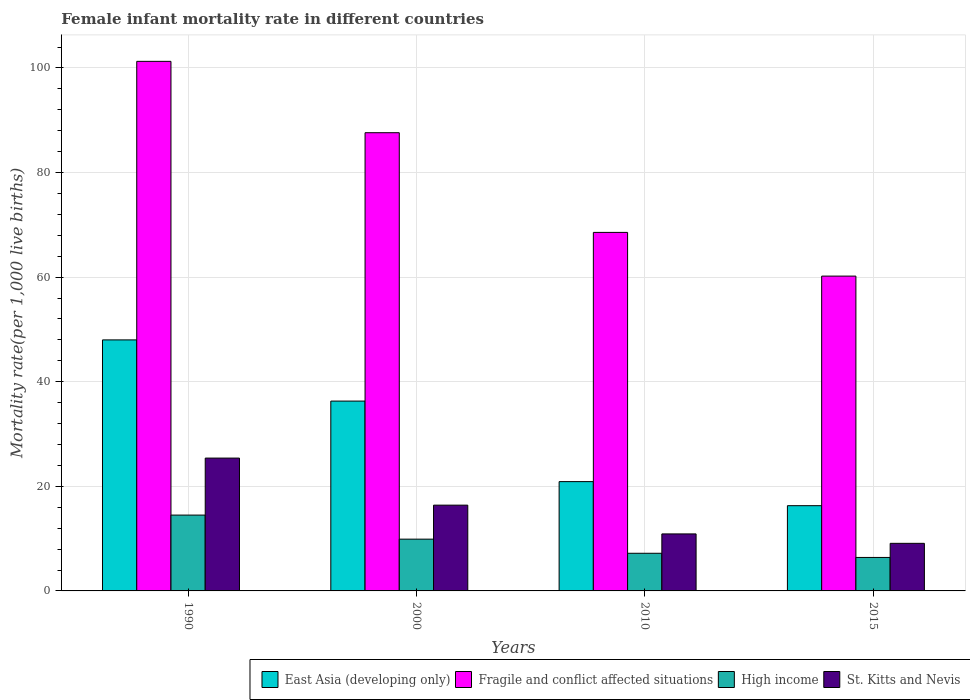How many different coloured bars are there?
Your response must be concise. 4. How many bars are there on the 1st tick from the left?
Provide a succinct answer. 4. How many bars are there on the 4th tick from the right?
Your answer should be compact. 4. What is the female infant mortality rate in East Asia (developing only) in 1990?
Give a very brief answer. 48. Across all years, what is the maximum female infant mortality rate in East Asia (developing only)?
Provide a short and direct response. 48. Across all years, what is the minimum female infant mortality rate in Fragile and conflict affected situations?
Offer a terse response. 60.2. In which year was the female infant mortality rate in High income minimum?
Provide a succinct answer. 2015. What is the total female infant mortality rate in Fragile and conflict affected situations in the graph?
Provide a succinct answer. 317.63. What is the difference between the female infant mortality rate in High income in 1990 and that in 2010?
Keep it short and to the point. 7.3. What is the difference between the female infant mortality rate in Fragile and conflict affected situations in 2010 and the female infant mortality rate in High income in 2015?
Provide a short and direct response. 62.15. What is the average female infant mortality rate in East Asia (developing only) per year?
Your answer should be very brief. 30.37. In the year 1990, what is the difference between the female infant mortality rate in East Asia (developing only) and female infant mortality rate in St. Kitts and Nevis?
Provide a succinct answer. 22.6. In how many years, is the female infant mortality rate in High income greater than 92?
Your answer should be compact. 0. What is the ratio of the female infant mortality rate in High income in 2000 to that in 2015?
Provide a succinct answer. 1.55. Is the female infant mortality rate in East Asia (developing only) in 2000 less than that in 2010?
Keep it short and to the point. No. Is the difference between the female infant mortality rate in East Asia (developing only) in 2000 and 2010 greater than the difference between the female infant mortality rate in St. Kitts and Nevis in 2000 and 2010?
Your answer should be compact. Yes. What is the difference between the highest and the second highest female infant mortality rate in High income?
Offer a terse response. 4.6. What is the difference between the highest and the lowest female infant mortality rate in East Asia (developing only)?
Ensure brevity in your answer.  31.7. In how many years, is the female infant mortality rate in East Asia (developing only) greater than the average female infant mortality rate in East Asia (developing only) taken over all years?
Offer a very short reply. 2. Is the sum of the female infant mortality rate in St. Kitts and Nevis in 1990 and 2000 greater than the maximum female infant mortality rate in East Asia (developing only) across all years?
Make the answer very short. No. What does the 4th bar from the left in 1990 represents?
Provide a short and direct response. St. Kitts and Nevis. What does the 2nd bar from the right in 2015 represents?
Give a very brief answer. High income. How many bars are there?
Provide a succinct answer. 16. Are all the bars in the graph horizontal?
Your answer should be compact. No. How many legend labels are there?
Offer a very short reply. 4. What is the title of the graph?
Offer a very short reply. Female infant mortality rate in different countries. Does "Belize" appear as one of the legend labels in the graph?
Provide a succinct answer. No. What is the label or title of the X-axis?
Keep it short and to the point. Years. What is the label or title of the Y-axis?
Your response must be concise. Mortality rate(per 1,0 live births). What is the Mortality rate(per 1,000 live births) in Fragile and conflict affected situations in 1990?
Give a very brief answer. 101.26. What is the Mortality rate(per 1,000 live births) in St. Kitts and Nevis in 1990?
Offer a terse response. 25.4. What is the Mortality rate(per 1,000 live births) in East Asia (developing only) in 2000?
Keep it short and to the point. 36.3. What is the Mortality rate(per 1,000 live births) in Fragile and conflict affected situations in 2000?
Your answer should be very brief. 87.62. What is the Mortality rate(per 1,000 live births) in High income in 2000?
Make the answer very short. 9.9. What is the Mortality rate(per 1,000 live births) of East Asia (developing only) in 2010?
Offer a very short reply. 20.9. What is the Mortality rate(per 1,000 live births) in Fragile and conflict affected situations in 2010?
Your response must be concise. 68.55. What is the Mortality rate(per 1,000 live births) of St. Kitts and Nevis in 2010?
Your answer should be very brief. 10.9. What is the Mortality rate(per 1,000 live births) of Fragile and conflict affected situations in 2015?
Make the answer very short. 60.2. Across all years, what is the maximum Mortality rate(per 1,000 live births) of East Asia (developing only)?
Offer a very short reply. 48. Across all years, what is the maximum Mortality rate(per 1,000 live births) of Fragile and conflict affected situations?
Ensure brevity in your answer.  101.26. Across all years, what is the maximum Mortality rate(per 1,000 live births) of St. Kitts and Nevis?
Offer a terse response. 25.4. Across all years, what is the minimum Mortality rate(per 1,000 live births) of East Asia (developing only)?
Your answer should be very brief. 16.3. Across all years, what is the minimum Mortality rate(per 1,000 live births) in Fragile and conflict affected situations?
Provide a short and direct response. 60.2. Across all years, what is the minimum Mortality rate(per 1,000 live births) of St. Kitts and Nevis?
Make the answer very short. 9.1. What is the total Mortality rate(per 1,000 live births) of East Asia (developing only) in the graph?
Offer a terse response. 121.5. What is the total Mortality rate(per 1,000 live births) of Fragile and conflict affected situations in the graph?
Make the answer very short. 317.63. What is the total Mortality rate(per 1,000 live births) in St. Kitts and Nevis in the graph?
Provide a succinct answer. 61.8. What is the difference between the Mortality rate(per 1,000 live births) in Fragile and conflict affected situations in 1990 and that in 2000?
Provide a succinct answer. 13.64. What is the difference between the Mortality rate(per 1,000 live births) of East Asia (developing only) in 1990 and that in 2010?
Ensure brevity in your answer.  27.1. What is the difference between the Mortality rate(per 1,000 live births) in Fragile and conflict affected situations in 1990 and that in 2010?
Your response must be concise. 32.71. What is the difference between the Mortality rate(per 1,000 live births) in St. Kitts and Nevis in 1990 and that in 2010?
Provide a short and direct response. 14.5. What is the difference between the Mortality rate(per 1,000 live births) of East Asia (developing only) in 1990 and that in 2015?
Keep it short and to the point. 31.7. What is the difference between the Mortality rate(per 1,000 live births) of Fragile and conflict affected situations in 1990 and that in 2015?
Your response must be concise. 41.06. What is the difference between the Mortality rate(per 1,000 live births) in High income in 1990 and that in 2015?
Your answer should be very brief. 8.1. What is the difference between the Mortality rate(per 1,000 live births) of Fragile and conflict affected situations in 2000 and that in 2010?
Your answer should be compact. 19.06. What is the difference between the Mortality rate(per 1,000 live births) of High income in 2000 and that in 2010?
Make the answer very short. 2.7. What is the difference between the Mortality rate(per 1,000 live births) in Fragile and conflict affected situations in 2000 and that in 2015?
Offer a terse response. 27.42. What is the difference between the Mortality rate(per 1,000 live births) in Fragile and conflict affected situations in 2010 and that in 2015?
Keep it short and to the point. 8.36. What is the difference between the Mortality rate(per 1,000 live births) in High income in 2010 and that in 2015?
Offer a very short reply. 0.8. What is the difference between the Mortality rate(per 1,000 live births) of East Asia (developing only) in 1990 and the Mortality rate(per 1,000 live births) of Fragile and conflict affected situations in 2000?
Your response must be concise. -39.62. What is the difference between the Mortality rate(per 1,000 live births) in East Asia (developing only) in 1990 and the Mortality rate(per 1,000 live births) in High income in 2000?
Offer a terse response. 38.1. What is the difference between the Mortality rate(per 1,000 live births) of East Asia (developing only) in 1990 and the Mortality rate(per 1,000 live births) of St. Kitts and Nevis in 2000?
Provide a succinct answer. 31.6. What is the difference between the Mortality rate(per 1,000 live births) of Fragile and conflict affected situations in 1990 and the Mortality rate(per 1,000 live births) of High income in 2000?
Your answer should be very brief. 91.36. What is the difference between the Mortality rate(per 1,000 live births) in Fragile and conflict affected situations in 1990 and the Mortality rate(per 1,000 live births) in St. Kitts and Nevis in 2000?
Make the answer very short. 84.86. What is the difference between the Mortality rate(per 1,000 live births) in High income in 1990 and the Mortality rate(per 1,000 live births) in St. Kitts and Nevis in 2000?
Give a very brief answer. -1.9. What is the difference between the Mortality rate(per 1,000 live births) in East Asia (developing only) in 1990 and the Mortality rate(per 1,000 live births) in Fragile and conflict affected situations in 2010?
Your answer should be very brief. -20.55. What is the difference between the Mortality rate(per 1,000 live births) in East Asia (developing only) in 1990 and the Mortality rate(per 1,000 live births) in High income in 2010?
Your answer should be very brief. 40.8. What is the difference between the Mortality rate(per 1,000 live births) of East Asia (developing only) in 1990 and the Mortality rate(per 1,000 live births) of St. Kitts and Nevis in 2010?
Provide a succinct answer. 37.1. What is the difference between the Mortality rate(per 1,000 live births) of Fragile and conflict affected situations in 1990 and the Mortality rate(per 1,000 live births) of High income in 2010?
Your answer should be very brief. 94.06. What is the difference between the Mortality rate(per 1,000 live births) of Fragile and conflict affected situations in 1990 and the Mortality rate(per 1,000 live births) of St. Kitts and Nevis in 2010?
Your answer should be compact. 90.36. What is the difference between the Mortality rate(per 1,000 live births) of East Asia (developing only) in 1990 and the Mortality rate(per 1,000 live births) of Fragile and conflict affected situations in 2015?
Offer a very short reply. -12.2. What is the difference between the Mortality rate(per 1,000 live births) of East Asia (developing only) in 1990 and the Mortality rate(per 1,000 live births) of High income in 2015?
Provide a short and direct response. 41.6. What is the difference between the Mortality rate(per 1,000 live births) of East Asia (developing only) in 1990 and the Mortality rate(per 1,000 live births) of St. Kitts and Nevis in 2015?
Keep it short and to the point. 38.9. What is the difference between the Mortality rate(per 1,000 live births) of Fragile and conflict affected situations in 1990 and the Mortality rate(per 1,000 live births) of High income in 2015?
Provide a short and direct response. 94.86. What is the difference between the Mortality rate(per 1,000 live births) in Fragile and conflict affected situations in 1990 and the Mortality rate(per 1,000 live births) in St. Kitts and Nevis in 2015?
Provide a succinct answer. 92.16. What is the difference between the Mortality rate(per 1,000 live births) in High income in 1990 and the Mortality rate(per 1,000 live births) in St. Kitts and Nevis in 2015?
Give a very brief answer. 5.4. What is the difference between the Mortality rate(per 1,000 live births) of East Asia (developing only) in 2000 and the Mortality rate(per 1,000 live births) of Fragile and conflict affected situations in 2010?
Your answer should be very brief. -32.25. What is the difference between the Mortality rate(per 1,000 live births) in East Asia (developing only) in 2000 and the Mortality rate(per 1,000 live births) in High income in 2010?
Your answer should be compact. 29.1. What is the difference between the Mortality rate(per 1,000 live births) in East Asia (developing only) in 2000 and the Mortality rate(per 1,000 live births) in St. Kitts and Nevis in 2010?
Offer a very short reply. 25.4. What is the difference between the Mortality rate(per 1,000 live births) in Fragile and conflict affected situations in 2000 and the Mortality rate(per 1,000 live births) in High income in 2010?
Give a very brief answer. 80.42. What is the difference between the Mortality rate(per 1,000 live births) in Fragile and conflict affected situations in 2000 and the Mortality rate(per 1,000 live births) in St. Kitts and Nevis in 2010?
Offer a very short reply. 76.72. What is the difference between the Mortality rate(per 1,000 live births) in East Asia (developing only) in 2000 and the Mortality rate(per 1,000 live births) in Fragile and conflict affected situations in 2015?
Give a very brief answer. -23.9. What is the difference between the Mortality rate(per 1,000 live births) of East Asia (developing only) in 2000 and the Mortality rate(per 1,000 live births) of High income in 2015?
Offer a terse response. 29.9. What is the difference between the Mortality rate(per 1,000 live births) in East Asia (developing only) in 2000 and the Mortality rate(per 1,000 live births) in St. Kitts and Nevis in 2015?
Offer a terse response. 27.2. What is the difference between the Mortality rate(per 1,000 live births) of Fragile and conflict affected situations in 2000 and the Mortality rate(per 1,000 live births) of High income in 2015?
Your answer should be compact. 81.22. What is the difference between the Mortality rate(per 1,000 live births) of Fragile and conflict affected situations in 2000 and the Mortality rate(per 1,000 live births) of St. Kitts and Nevis in 2015?
Keep it short and to the point. 78.52. What is the difference between the Mortality rate(per 1,000 live births) of High income in 2000 and the Mortality rate(per 1,000 live births) of St. Kitts and Nevis in 2015?
Keep it short and to the point. 0.8. What is the difference between the Mortality rate(per 1,000 live births) in East Asia (developing only) in 2010 and the Mortality rate(per 1,000 live births) in Fragile and conflict affected situations in 2015?
Give a very brief answer. -39.3. What is the difference between the Mortality rate(per 1,000 live births) of East Asia (developing only) in 2010 and the Mortality rate(per 1,000 live births) of St. Kitts and Nevis in 2015?
Keep it short and to the point. 11.8. What is the difference between the Mortality rate(per 1,000 live births) in Fragile and conflict affected situations in 2010 and the Mortality rate(per 1,000 live births) in High income in 2015?
Keep it short and to the point. 62.15. What is the difference between the Mortality rate(per 1,000 live births) of Fragile and conflict affected situations in 2010 and the Mortality rate(per 1,000 live births) of St. Kitts and Nevis in 2015?
Offer a very short reply. 59.45. What is the average Mortality rate(per 1,000 live births) of East Asia (developing only) per year?
Make the answer very short. 30.38. What is the average Mortality rate(per 1,000 live births) of Fragile and conflict affected situations per year?
Your answer should be very brief. 79.41. What is the average Mortality rate(per 1,000 live births) in St. Kitts and Nevis per year?
Keep it short and to the point. 15.45. In the year 1990, what is the difference between the Mortality rate(per 1,000 live births) in East Asia (developing only) and Mortality rate(per 1,000 live births) in Fragile and conflict affected situations?
Your answer should be compact. -53.26. In the year 1990, what is the difference between the Mortality rate(per 1,000 live births) of East Asia (developing only) and Mortality rate(per 1,000 live births) of High income?
Offer a terse response. 33.5. In the year 1990, what is the difference between the Mortality rate(per 1,000 live births) of East Asia (developing only) and Mortality rate(per 1,000 live births) of St. Kitts and Nevis?
Make the answer very short. 22.6. In the year 1990, what is the difference between the Mortality rate(per 1,000 live births) in Fragile and conflict affected situations and Mortality rate(per 1,000 live births) in High income?
Offer a very short reply. 86.76. In the year 1990, what is the difference between the Mortality rate(per 1,000 live births) in Fragile and conflict affected situations and Mortality rate(per 1,000 live births) in St. Kitts and Nevis?
Give a very brief answer. 75.86. In the year 2000, what is the difference between the Mortality rate(per 1,000 live births) of East Asia (developing only) and Mortality rate(per 1,000 live births) of Fragile and conflict affected situations?
Your response must be concise. -51.32. In the year 2000, what is the difference between the Mortality rate(per 1,000 live births) in East Asia (developing only) and Mortality rate(per 1,000 live births) in High income?
Your response must be concise. 26.4. In the year 2000, what is the difference between the Mortality rate(per 1,000 live births) of Fragile and conflict affected situations and Mortality rate(per 1,000 live births) of High income?
Your answer should be very brief. 77.72. In the year 2000, what is the difference between the Mortality rate(per 1,000 live births) of Fragile and conflict affected situations and Mortality rate(per 1,000 live births) of St. Kitts and Nevis?
Provide a succinct answer. 71.22. In the year 2000, what is the difference between the Mortality rate(per 1,000 live births) in High income and Mortality rate(per 1,000 live births) in St. Kitts and Nevis?
Make the answer very short. -6.5. In the year 2010, what is the difference between the Mortality rate(per 1,000 live births) of East Asia (developing only) and Mortality rate(per 1,000 live births) of Fragile and conflict affected situations?
Provide a short and direct response. -47.65. In the year 2010, what is the difference between the Mortality rate(per 1,000 live births) of East Asia (developing only) and Mortality rate(per 1,000 live births) of St. Kitts and Nevis?
Provide a succinct answer. 10. In the year 2010, what is the difference between the Mortality rate(per 1,000 live births) in Fragile and conflict affected situations and Mortality rate(per 1,000 live births) in High income?
Provide a succinct answer. 61.35. In the year 2010, what is the difference between the Mortality rate(per 1,000 live births) of Fragile and conflict affected situations and Mortality rate(per 1,000 live births) of St. Kitts and Nevis?
Offer a terse response. 57.65. In the year 2015, what is the difference between the Mortality rate(per 1,000 live births) of East Asia (developing only) and Mortality rate(per 1,000 live births) of Fragile and conflict affected situations?
Offer a very short reply. -43.9. In the year 2015, what is the difference between the Mortality rate(per 1,000 live births) of East Asia (developing only) and Mortality rate(per 1,000 live births) of High income?
Your response must be concise. 9.9. In the year 2015, what is the difference between the Mortality rate(per 1,000 live births) in Fragile and conflict affected situations and Mortality rate(per 1,000 live births) in High income?
Ensure brevity in your answer.  53.8. In the year 2015, what is the difference between the Mortality rate(per 1,000 live births) of Fragile and conflict affected situations and Mortality rate(per 1,000 live births) of St. Kitts and Nevis?
Your response must be concise. 51.1. In the year 2015, what is the difference between the Mortality rate(per 1,000 live births) of High income and Mortality rate(per 1,000 live births) of St. Kitts and Nevis?
Your answer should be compact. -2.7. What is the ratio of the Mortality rate(per 1,000 live births) in East Asia (developing only) in 1990 to that in 2000?
Make the answer very short. 1.32. What is the ratio of the Mortality rate(per 1,000 live births) of Fragile and conflict affected situations in 1990 to that in 2000?
Offer a terse response. 1.16. What is the ratio of the Mortality rate(per 1,000 live births) of High income in 1990 to that in 2000?
Ensure brevity in your answer.  1.46. What is the ratio of the Mortality rate(per 1,000 live births) in St. Kitts and Nevis in 1990 to that in 2000?
Give a very brief answer. 1.55. What is the ratio of the Mortality rate(per 1,000 live births) of East Asia (developing only) in 1990 to that in 2010?
Your answer should be very brief. 2.3. What is the ratio of the Mortality rate(per 1,000 live births) in Fragile and conflict affected situations in 1990 to that in 2010?
Keep it short and to the point. 1.48. What is the ratio of the Mortality rate(per 1,000 live births) in High income in 1990 to that in 2010?
Provide a succinct answer. 2.01. What is the ratio of the Mortality rate(per 1,000 live births) in St. Kitts and Nevis in 1990 to that in 2010?
Offer a very short reply. 2.33. What is the ratio of the Mortality rate(per 1,000 live births) in East Asia (developing only) in 1990 to that in 2015?
Make the answer very short. 2.94. What is the ratio of the Mortality rate(per 1,000 live births) of Fragile and conflict affected situations in 1990 to that in 2015?
Make the answer very short. 1.68. What is the ratio of the Mortality rate(per 1,000 live births) of High income in 1990 to that in 2015?
Your response must be concise. 2.27. What is the ratio of the Mortality rate(per 1,000 live births) of St. Kitts and Nevis in 1990 to that in 2015?
Provide a succinct answer. 2.79. What is the ratio of the Mortality rate(per 1,000 live births) of East Asia (developing only) in 2000 to that in 2010?
Offer a very short reply. 1.74. What is the ratio of the Mortality rate(per 1,000 live births) in Fragile and conflict affected situations in 2000 to that in 2010?
Ensure brevity in your answer.  1.28. What is the ratio of the Mortality rate(per 1,000 live births) of High income in 2000 to that in 2010?
Ensure brevity in your answer.  1.38. What is the ratio of the Mortality rate(per 1,000 live births) of St. Kitts and Nevis in 2000 to that in 2010?
Make the answer very short. 1.5. What is the ratio of the Mortality rate(per 1,000 live births) of East Asia (developing only) in 2000 to that in 2015?
Ensure brevity in your answer.  2.23. What is the ratio of the Mortality rate(per 1,000 live births) in Fragile and conflict affected situations in 2000 to that in 2015?
Make the answer very short. 1.46. What is the ratio of the Mortality rate(per 1,000 live births) of High income in 2000 to that in 2015?
Ensure brevity in your answer.  1.55. What is the ratio of the Mortality rate(per 1,000 live births) in St. Kitts and Nevis in 2000 to that in 2015?
Keep it short and to the point. 1.8. What is the ratio of the Mortality rate(per 1,000 live births) of East Asia (developing only) in 2010 to that in 2015?
Keep it short and to the point. 1.28. What is the ratio of the Mortality rate(per 1,000 live births) in Fragile and conflict affected situations in 2010 to that in 2015?
Keep it short and to the point. 1.14. What is the ratio of the Mortality rate(per 1,000 live births) of High income in 2010 to that in 2015?
Make the answer very short. 1.12. What is the ratio of the Mortality rate(per 1,000 live births) of St. Kitts and Nevis in 2010 to that in 2015?
Provide a succinct answer. 1.2. What is the difference between the highest and the second highest Mortality rate(per 1,000 live births) of Fragile and conflict affected situations?
Your answer should be compact. 13.64. What is the difference between the highest and the lowest Mortality rate(per 1,000 live births) in East Asia (developing only)?
Offer a very short reply. 31.7. What is the difference between the highest and the lowest Mortality rate(per 1,000 live births) in Fragile and conflict affected situations?
Give a very brief answer. 41.06. What is the difference between the highest and the lowest Mortality rate(per 1,000 live births) in High income?
Your answer should be compact. 8.1. 